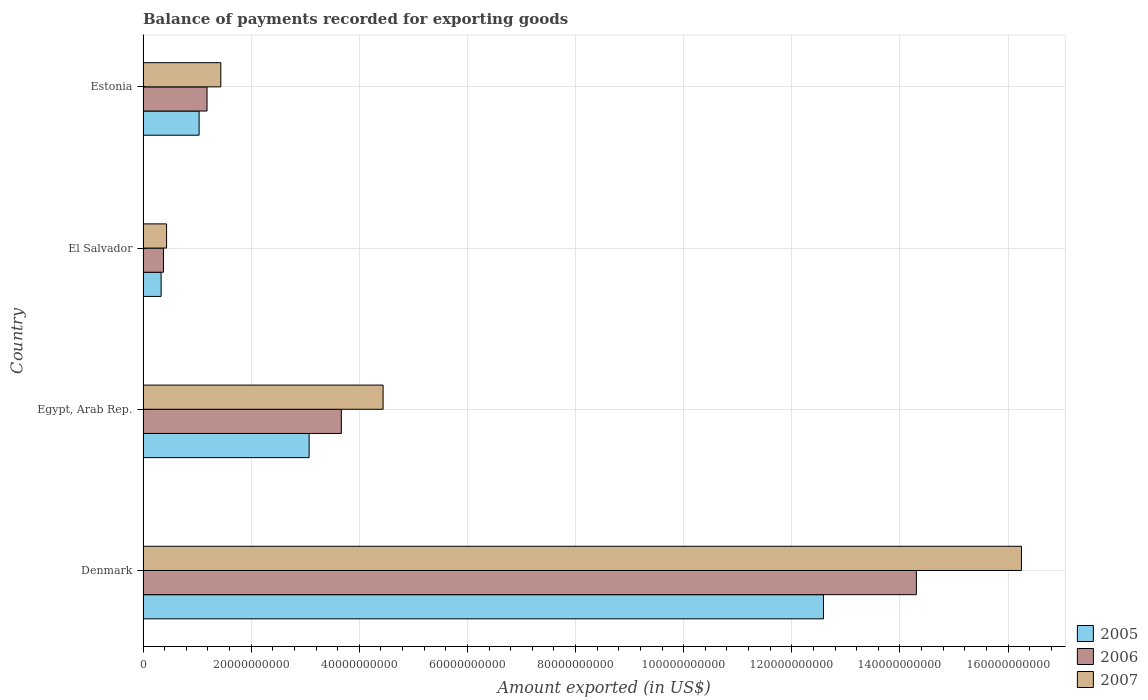How many different coloured bars are there?
Give a very brief answer. 3. How many groups of bars are there?
Your response must be concise. 4. Are the number of bars on each tick of the Y-axis equal?
Provide a succinct answer. Yes. How many bars are there on the 2nd tick from the top?
Keep it short and to the point. 3. How many bars are there on the 4th tick from the bottom?
Offer a terse response. 3. What is the label of the 3rd group of bars from the top?
Your answer should be very brief. Egypt, Arab Rep. In how many cases, is the number of bars for a given country not equal to the number of legend labels?
Your answer should be compact. 0. What is the amount exported in 2006 in Estonia?
Give a very brief answer. 1.18e+1. Across all countries, what is the maximum amount exported in 2007?
Provide a succinct answer. 1.62e+11. Across all countries, what is the minimum amount exported in 2007?
Keep it short and to the point. 4.35e+09. In which country was the amount exported in 2007 maximum?
Your response must be concise. Denmark. In which country was the amount exported in 2006 minimum?
Your answer should be very brief. El Salvador. What is the total amount exported in 2005 in the graph?
Provide a succinct answer. 1.70e+11. What is the difference between the amount exported in 2006 in Egypt, Arab Rep. and that in El Salvador?
Offer a very short reply. 3.29e+1. What is the difference between the amount exported in 2006 in Estonia and the amount exported in 2005 in Egypt, Arab Rep.?
Provide a succinct answer. -1.89e+1. What is the average amount exported in 2007 per country?
Ensure brevity in your answer.  5.64e+1. What is the difference between the amount exported in 2007 and amount exported in 2006 in Egypt, Arab Rep.?
Your answer should be compact. 7.72e+09. What is the ratio of the amount exported in 2006 in Denmark to that in Egypt, Arab Rep.?
Ensure brevity in your answer.  3.9. Is the difference between the amount exported in 2007 in Denmark and El Salvador greater than the difference between the amount exported in 2006 in Denmark and El Salvador?
Provide a short and direct response. Yes. What is the difference between the highest and the second highest amount exported in 2007?
Ensure brevity in your answer.  1.18e+11. What is the difference between the highest and the lowest amount exported in 2007?
Keep it short and to the point. 1.58e+11. In how many countries, is the amount exported in 2006 greater than the average amount exported in 2006 taken over all countries?
Offer a terse response. 1. Is the sum of the amount exported in 2007 in Denmark and El Salvador greater than the maximum amount exported in 2006 across all countries?
Keep it short and to the point. Yes. What does the 3rd bar from the top in El Salvador represents?
Your answer should be very brief. 2005. What does the 3rd bar from the bottom in Estonia represents?
Offer a very short reply. 2007. How many bars are there?
Provide a short and direct response. 12. Are all the bars in the graph horizontal?
Provide a succinct answer. Yes. How many countries are there in the graph?
Keep it short and to the point. 4. Are the values on the major ticks of X-axis written in scientific E-notation?
Give a very brief answer. No. Where does the legend appear in the graph?
Offer a very short reply. Bottom right. How many legend labels are there?
Offer a terse response. 3. How are the legend labels stacked?
Ensure brevity in your answer.  Vertical. What is the title of the graph?
Keep it short and to the point. Balance of payments recorded for exporting goods. What is the label or title of the X-axis?
Provide a succinct answer. Amount exported (in US$). What is the Amount exported (in US$) in 2005 in Denmark?
Your answer should be very brief. 1.26e+11. What is the Amount exported (in US$) in 2006 in Denmark?
Provide a short and direct response. 1.43e+11. What is the Amount exported (in US$) of 2007 in Denmark?
Provide a succinct answer. 1.62e+11. What is the Amount exported (in US$) in 2005 in Egypt, Arab Rep.?
Offer a terse response. 3.07e+1. What is the Amount exported (in US$) of 2006 in Egypt, Arab Rep.?
Offer a terse response. 3.67e+1. What is the Amount exported (in US$) of 2007 in Egypt, Arab Rep.?
Offer a very short reply. 4.44e+1. What is the Amount exported (in US$) of 2005 in El Salvador?
Your answer should be very brief. 3.34e+09. What is the Amount exported (in US$) in 2006 in El Salvador?
Offer a terse response. 3.77e+09. What is the Amount exported (in US$) of 2007 in El Salvador?
Keep it short and to the point. 4.35e+09. What is the Amount exported (in US$) in 2005 in Estonia?
Offer a very short reply. 1.04e+1. What is the Amount exported (in US$) in 2006 in Estonia?
Ensure brevity in your answer.  1.18e+1. What is the Amount exported (in US$) of 2007 in Estonia?
Give a very brief answer. 1.44e+1. Across all countries, what is the maximum Amount exported (in US$) in 2005?
Provide a succinct answer. 1.26e+11. Across all countries, what is the maximum Amount exported (in US$) of 2006?
Offer a terse response. 1.43e+11. Across all countries, what is the maximum Amount exported (in US$) of 2007?
Give a very brief answer. 1.62e+11. Across all countries, what is the minimum Amount exported (in US$) of 2005?
Keep it short and to the point. 3.34e+09. Across all countries, what is the minimum Amount exported (in US$) of 2006?
Ensure brevity in your answer.  3.77e+09. Across all countries, what is the minimum Amount exported (in US$) of 2007?
Keep it short and to the point. 4.35e+09. What is the total Amount exported (in US$) of 2005 in the graph?
Your response must be concise. 1.70e+11. What is the total Amount exported (in US$) in 2006 in the graph?
Provide a short and direct response. 1.95e+11. What is the total Amount exported (in US$) of 2007 in the graph?
Provide a short and direct response. 2.26e+11. What is the difference between the Amount exported (in US$) of 2005 in Denmark and that in Egypt, Arab Rep.?
Give a very brief answer. 9.51e+1. What is the difference between the Amount exported (in US$) in 2006 in Denmark and that in Egypt, Arab Rep.?
Ensure brevity in your answer.  1.06e+11. What is the difference between the Amount exported (in US$) of 2007 in Denmark and that in Egypt, Arab Rep.?
Provide a succinct answer. 1.18e+11. What is the difference between the Amount exported (in US$) of 2005 in Denmark and that in El Salvador?
Your answer should be very brief. 1.23e+11. What is the difference between the Amount exported (in US$) in 2006 in Denmark and that in El Salvador?
Ensure brevity in your answer.  1.39e+11. What is the difference between the Amount exported (in US$) in 2007 in Denmark and that in El Salvador?
Give a very brief answer. 1.58e+11. What is the difference between the Amount exported (in US$) in 2005 in Denmark and that in Estonia?
Keep it short and to the point. 1.15e+11. What is the difference between the Amount exported (in US$) in 2006 in Denmark and that in Estonia?
Your response must be concise. 1.31e+11. What is the difference between the Amount exported (in US$) in 2007 in Denmark and that in Estonia?
Offer a very short reply. 1.48e+11. What is the difference between the Amount exported (in US$) of 2005 in Egypt, Arab Rep. and that in El Salvador?
Your answer should be compact. 2.74e+1. What is the difference between the Amount exported (in US$) of 2006 in Egypt, Arab Rep. and that in El Salvador?
Make the answer very short. 3.29e+1. What is the difference between the Amount exported (in US$) of 2007 in Egypt, Arab Rep. and that in El Salvador?
Offer a very short reply. 4.00e+1. What is the difference between the Amount exported (in US$) in 2005 in Egypt, Arab Rep. and that in Estonia?
Give a very brief answer. 2.03e+1. What is the difference between the Amount exported (in US$) in 2006 in Egypt, Arab Rep. and that in Estonia?
Make the answer very short. 2.48e+1. What is the difference between the Amount exported (in US$) of 2007 in Egypt, Arab Rep. and that in Estonia?
Ensure brevity in your answer.  3.00e+1. What is the difference between the Amount exported (in US$) of 2005 in El Salvador and that in Estonia?
Provide a short and direct response. -7.03e+09. What is the difference between the Amount exported (in US$) in 2006 in El Salvador and that in Estonia?
Ensure brevity in your answer.  -8.06e+09. What is the difference between the Amount exported (in US$) of 2007 in El Salvador and that in Estonia?
Provide a succinct answer. -1.00e+1. What is the difference between the Amount exported (in US$) in 2005 in Denmark and the Amount exported (in US$) in 2006 in Egypt, Arab Rep.?
Your answer should be compact. 8.92e+1. What is the difference between the Amount exported (in US$) in 2005 in Denmark and the Amount exported (in US$) in 2007 in Egypt, Arab Rep.?
Your answer should be very brief. 8.15e+1. What is the difference between the Amount exported (in US$) of 2006 in Denmark and the Amount exported (in US$) of 2007 in Egypt, Arab Rep.?
Provide a short and direct response. 9.86e+1. What is the difference between the Amount exported (in US$) in 2005 in Denmark and the Amount exported (in US$) in 2006 in El Salvador?
Give a very brief answer. 1.22e+11. What is the difference between the Amount exported (in US$) in 2005 in Denmark and the Amount exported (in US$) in 2007 in El Salvador?
Your response must be concise. 1.22e+11. What is the difference between the Amount exported (in US$) of 2006 in Denmark and the Amount exported (in US$) of 2007 in El Salvador?
Make the answer very short. 1.39e+11. What is the difference between the Amount exported (in US$) of 2005 in Denmark and the Amount exported (in US$) of 2006 in Estonia?
Make the answer very short. 1.14e+11. What is the difference between the Amount exported (in US$) in 2005 in Denmark and the Amount exported (in US$) in 2007 in Estonia?
Offer a very short reply. 1.11e+11. What is the difference between the Amount exported (in US$) of 2006 in Denmark and the Amount exported (in US$) of 2007 in Estonia?
Keep it short and to the point. 1.29e+11. What is the difference between the Amount exported (in US$) in 2005 in Egypt, Arab Rep. and the Amount exported (in US$) in 2006 in El Salvador?
Give a very brief answer. 2.69e+1. What is the difference between the Amount exported (in US$) in 2005 in Egypt, Arab Rep. and the Amount exported (in US$) in 2007 in El Salvador?
Provide a short and direct response. 2.64e+1. What is the difference between the Amount exported (in US$) of 2006 in Egypt, Arab Rep. and the Amount exported (in US$) of 2007 in El Salvador?
Keep it short and to the point. 3.23e+1. What is the difference between the Amount exported (in US$) of 2005 in Egypt, Arab Rep. and the Amount exported (in US$) of 2006 in Estonia?
Make the answer very short. 1.89e+1. What is the difference between the Amount exported (in US$) in 2005 in Egypt, Arab Rep. and the Amount exported (in US$) in 2007 in Estonia?
Provide a short and direct response. 1.63e+1. What is the difference between the Amount exported (in US$) in 2006 in Egypt, Arab Rep. and the Amount exported (in US$) in 2007 in Estonia?
Your answer should be very brief. 2.23e+1. What is the difference between the Amount exported (in US$) in 2005 in El Salvador and the Amount exported (in US$) in 2006 in Estonia?
Offer a very short reply. -8.49e+09. What is the difference between the Amount exported (in US$) in 2005 in El Salvador and the Amount exported (in US$) in 2007 in Estonia?
Keep it short and to the point. -1.10e+1. What is the difference between the Amount exported (in US$) in 2006 in El Salvador and the Amount exported (in US$) in 2007 in Estonia?
Offer a very short reply. -1.06e+1. What is the average Amount exported (in US$) in 2005 per country?
Ensure brevity in your answer.  4.26e+1. What is the average Amount exported (in US$) of 2006 per country?
Provide a short and direct response. 4.88e+1. What is the average Amount exported (in US$) in 2007 per country?
Ensure brevity in your answer.  5.64e+1. What is the difference between the Amount exported (in US$) of 2005 and Amount exported (in US$) of 2006 in Denmark?
Offer a very short reply. -1.72e+1. What is the difference between the Amount exported (in US$) in 2005 and Amount exported (in US$) in 2007 in Denmark?
Your answer should be compact. -3.66e+1. What is the difference between the Amount exported (in US$) in 2006 and Amount exported (in US$) in 2007 in Denmark?
Offer a very short reply. -1.94e+1. What is the difference between the Amount exported (in US$) of 2005 and Amount exported (in US$) of 2006 in Egypt, Arab Rep.?
Your response must be concise. -5.96e+09. What is the difference between the Amount exported (in US$) of 2005 and Amount exported (in US$) of 2007 in Egypt, Arab Rep.?
Give a very brief answer. -1.37e+1. What is the difference between the Amount exported (in US$) of 2006 and Amount exported (in US$) of 2007 in Egypt, Arab Rep.?
Make the answer very short. -7.72e+09. What is the difference between the Amount exported (in US$) in 2005 and Amount exported (in US$) in 2006 in El Salvador?
Your answer should be compact. -4.29e+08. What is the difference between the Amount exported (in US$) of 2005 and Amount exported (in US$) of 2007 in El Salvador?
Your answer should be very brief. -1.01e+09. What is the difference between the Amount exported (in US$) in 2006 and Amount exported (in US$) in 2007 in El Salvador?
Offer a terse response. -5.79e+08. What is the difference between the Amount exported (in US$) of 2005 and Amount exported (in US$) of 2006 in Estonia?
Offer a terse response. -1.46e+09. What is the difference between the Amount exported (in US$) of 2005 and Amount exported (in US$) of 2007 in Estonia?
Ensure brevity in your answer.  -4.01e+09. What is the difference between the Amount exported (in US$) of 2006 and Amount exported (in US$) of 2007 in Estonia?
Ensure brevity in your answer.  -2.55e+09. What is the ratio of the Amount exported (in US$) in 2005 in Denmark to that in Egypt, Arab Rep.?
Offer a terse response. 4.1. What is the ratio of the Amount exported (in US$) of 2006 in Denmark to that in Egypt, Arab Rep.?
Make the answer very short. 3.9. What is the ratio of the Amount exported (in US$) of 2007 in Denmark to that in Egypt, Arab Rep.?
Offer a very short reply. 3.66. What is the ratio of the Amount exported (in US$) in 2005 in Denmark to that in El Salvador?
Offer a very short reply. 37.66. What is the ratio of the Amount exported (in US$) of 2006 in Denmark to that in El Salvador?
Keep it short and to the point. 37.93. What is the ratio of the Amount exported (in US$) of 2007 in Denmark to that in El Salvador?
Your answer should be compact. 37.36. What is the ratio of the Amount exported (in US$) of 2005 in Denmark to that in Estonia?
Provide a succinct answer. 12.14. What is the ratio of the Amount exported (in US$) of 2006 in Denmark to that in Estonia?
Your answer should be very brief. 12.09. What is the ratio of the Amount exported (in US$) of 2007 in Denmark to that in Estonia?
Offer a very short reply. 11.3. What is the ratio of the Amount exported (in US$) of 2005 in Egypt, Arab Rep. to that in El Salvador?
Ensure brevity in your answer.  9.19. What is the ratio of the Amount exported (in US$) of 2006 in Egypt, Arab Rep. to that in El Salvador?
Provide a short and direct response. 9.73. What is the ratio of the Amount exported (in US$) of 2007 in Egypt, Arab Rep. to that in El Salvador?
Give a very brief answer. 10.21. What is the ratio of the Amount exported (in US$) in 2005 in Egypt, Arab Rep. to that in Estonia?
Offer a terse response. 2.96. What is the ratio of the Amount exported (in US$) of 2006 in Egypt, Arab Rep. to that in Estonia?
Ensure brevity in your answer.  3.1. What is the ratio of the Amount exported (in US$) of 2007 in Egypt, Arab Rep. to that in Estonia?
Your answer should be very brief. 3.09. What is the ratio of the Amount exported (in US$) in 2005 in El Salvador to that in Estonia?
Offer a very short reply. 0.32. What is the ratio of the Amount exported (in US$) in 2006 in El Salvador to that in Estonia?
Provide a succinct answer. 0.32. What is the ratio of the Amount exported (in US$) of 2007 in El Salvador to that in Estonia?
Your answer should be very brief. 0.3. What is the difference between the highest and the second highest Amount exported (in US$) in 2005?
Offer a very short reply. 9.51e+1. What is the difference between the highest and the second highest Amount exported (in US$) in 2006?
Offer a terse response. 1.06e+11. What is the difference between the highest and the second highest Amount exported (in US$) in 2007?
Ensure brevity in your answer.  1.18e+11. What is the difference between the highest and the lowest Amount exported (in US$) of 2005?
Keep it short and to the point. 1.23e+11. What is the difference between the highest and the lowest Amount exported (in US$) in 2006?
Your response must be concise. 1.39e+11. What is the difference between the highest and the lowest Amount exported (in US$) in 2007?
Offer a very short reply. 1.58e+11. 